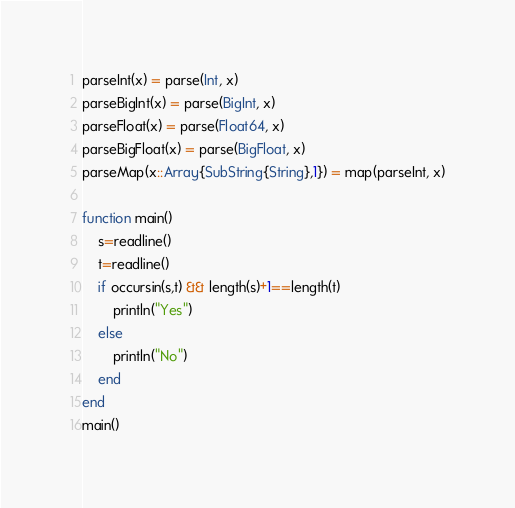Convert code to text. <code><loc_0><loc_0><loc_500><loc_500><_Julia_>parseInt(x) = parse(Int, x)
parseBigInt(x) = parse(BigInt, x)
parseFloat(x) = parse(Float64, x)
parseBigFloat(x) = parse(BigFloat, x)
parseMap(x::Array{SubString{String},1}) = map(parseInt, x)

function main()
    s=readline()
    t=readline()
    if occursin(s,t) && length(s)+1==length(t)
        println("Yes")
    else
        println("No")
    end
end
main()</code> 